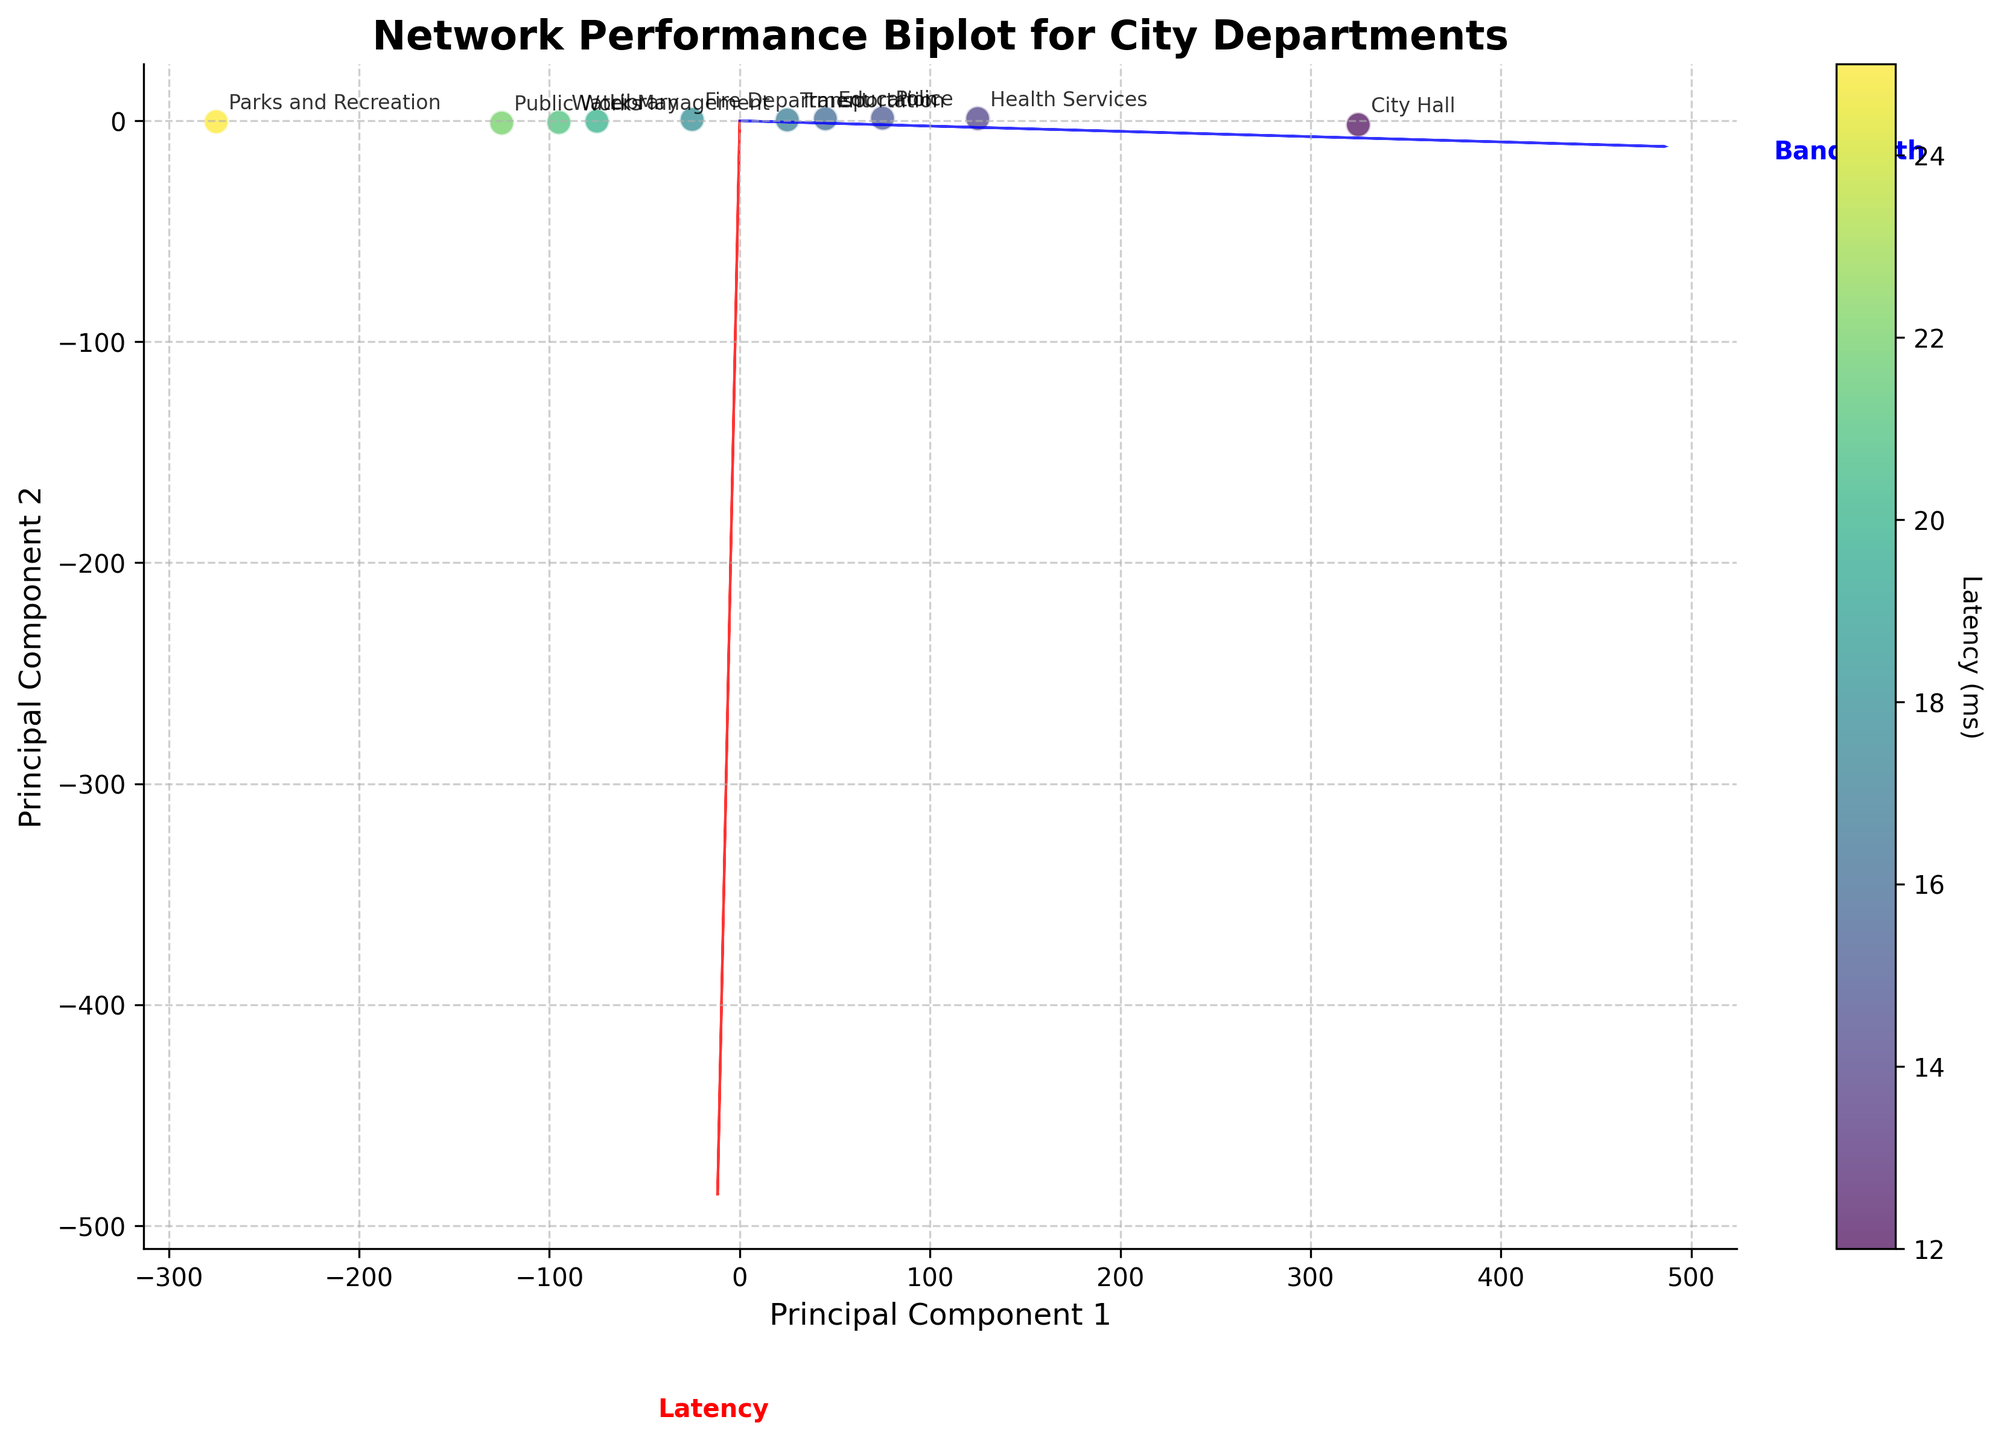What is the title of the plot? The title is usually displayed at the top of the plot and is used to give a brief description of what the plot represents. The title in this case is "Network Performance Biplot for City Departments".
Answer: Network Performance Biplot for City Departments How many city departments are represented in the plot? You can count the number of unique points in the plot, each labeled by a department name. There are 10 distinct points, each representing a different department.
Answer: 10 Which department has the lowest latency? Look at the color gradient and the labels of the points. The point with the darkest color represents the lowest latency, and it is labeled "City Hall".
Answer: City Hall Which department has the highest bandwidth? The highest bandwidth corresponds to the data point farthest along the "Bandwidth" feature vector (blue arrow). This point is also labeled "City Hall".
Answer: City Hall What is the approximate latency of the "Library" department? The latency values are represented by the color gradient. The "Library" point is around a medium-dark color shade, corresponding to the value shown in the colorbar as approximately 20 ms.
Answer: 20 ms Which departments are clustered close to each other in terms of network performance? Points that are close to each other on the plot are similar in terms of the two principal components. "Library", "Fire Department", and "Public Works" are clustered near each other.
Answer: Library, Fire Department, Public Works How does the bandwidth of the "Parks and Recreation" department compare to that of the "Police" department? Find the two points on the plot. "Parks and Recreation" is closer to the low end of the "Bandwidth" vector, indicating lower bandwidth compared to "Police".
Answer: Lower What relationship can you deduce between latency and bandwidth from the biplot? The directions of the feature vectors indicate the relationship. The arrows for latency and bandwidth are nearly orthogonal, suggesting little correlation between high latency and high bandwidth in this dataset.
Answer: Little to no correlation Which department has a moderate latency but relatively high bandwidth? Identify the point with medium-dark color (indicating moderate latency) and a position farther along the "Bandwidth" vector. "Health Services" is such a department.
Answer: Health Services Is there any department with both high latency and low bandwidth? Identify the point with lighter color (indicating higher latency) and position closer to the origin in terms of the "Bandwidth" vector. "Parks and Recreation" fits this criteria.
Answer: Parks and Recreation 